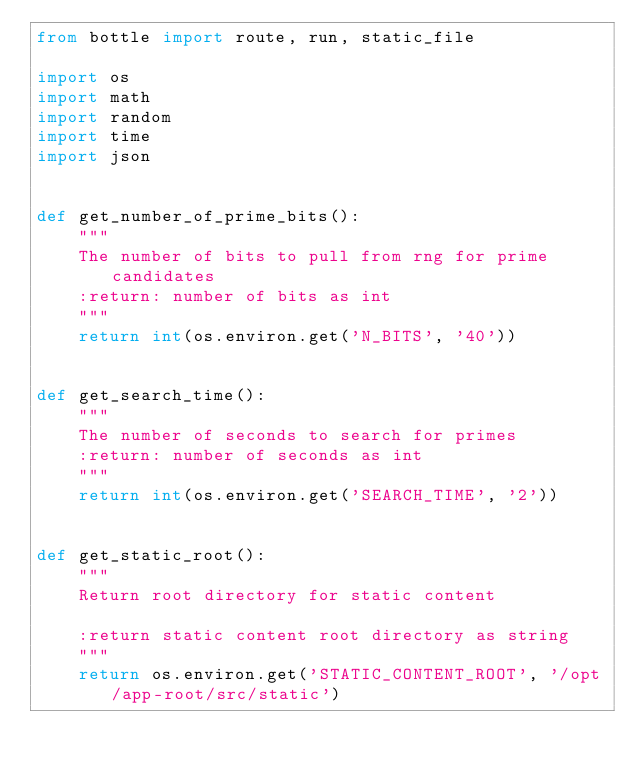<code> <loc_0><loc_0><loc_500><loc_500><_Python_>from bottle import route, run, static_file

import os
import math
import random
import time
import json


def get_number_of_prime_bits():
    """
    The number of bits to pull from rng for prime candidates
    :return: number of bits as int
    """
    return int(os.environ.get('N_BITS', '40'))


def get_search_time():
    """
    The number of seconds to search for primes
    :return: number of seconds as int
    """
    return int(os.environ.get('SEARCH_TIME', '2'))


def get_static_root():
    """
    Return root directory for static content

    :return static content root directory as string
    """
    return os.environ.get('STATIC_CONTENT_ROOT', '/opt/app-root/src/static')

</code> 